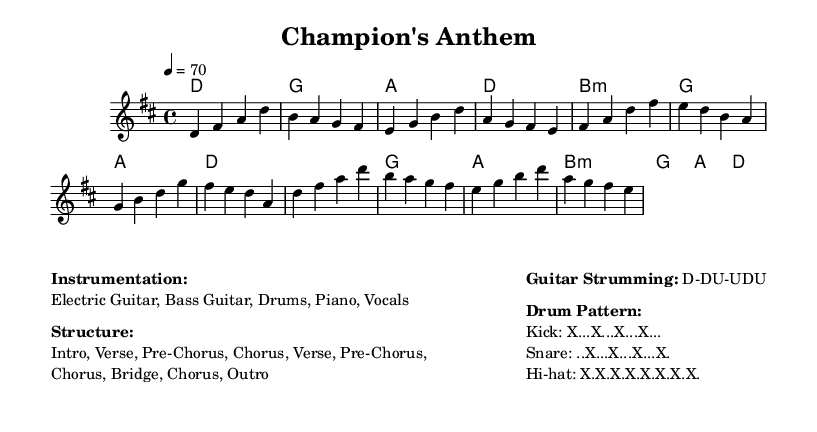What is the key signature of this music? The key signature is D major, which contains two sharps (F# and C#).
Answer: D major What is the time signature of the piece? The time signature is 4/4, indicating four beats per measure.
Answer: 4/4 What is the tempo marking of the song? The tempo marking is 70 beats per minute, indicating a moderate pace.
Answer: 70 How many sections are in the structure of the song? The structure contains five distinct sections: Intro, Verse, Pre-Chorus, Chorus, and Bridge, along with the Outro.
Answer: Five What is the strumming pattern indicated for the guitar? The strumming pattern described is Down-Down-Up-Down-Up, which is commonly used in rock music for a driving rhythm.
Answer: Down-Down-Up-Down-Up In which section do the harmonies change to a minor? The harmonies change to minor in the Pre-Chorus section, where a B minor chord is introduced.
Answer: Pre-Chorus What instruments are indicated for this rock ballad? The instrumentation includes Electric Guitar, Bass Guitar, Drums, Piano, and Vocals, showcasing a full rock ensemble.
Answer: Electric Guitar, Bass Guitar, Drums, Piano, Vocals 